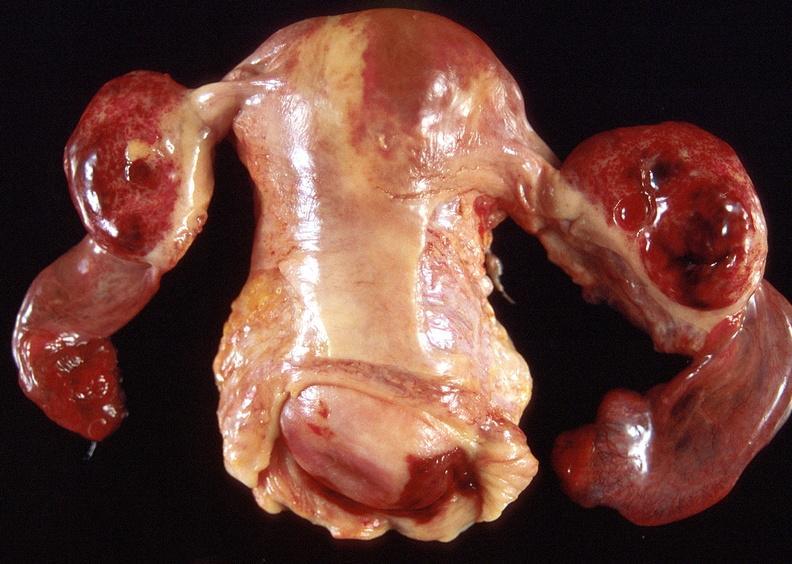does that show ovarian cysts, hemorrhagic?
Answer the question using a single word or phrase. No 